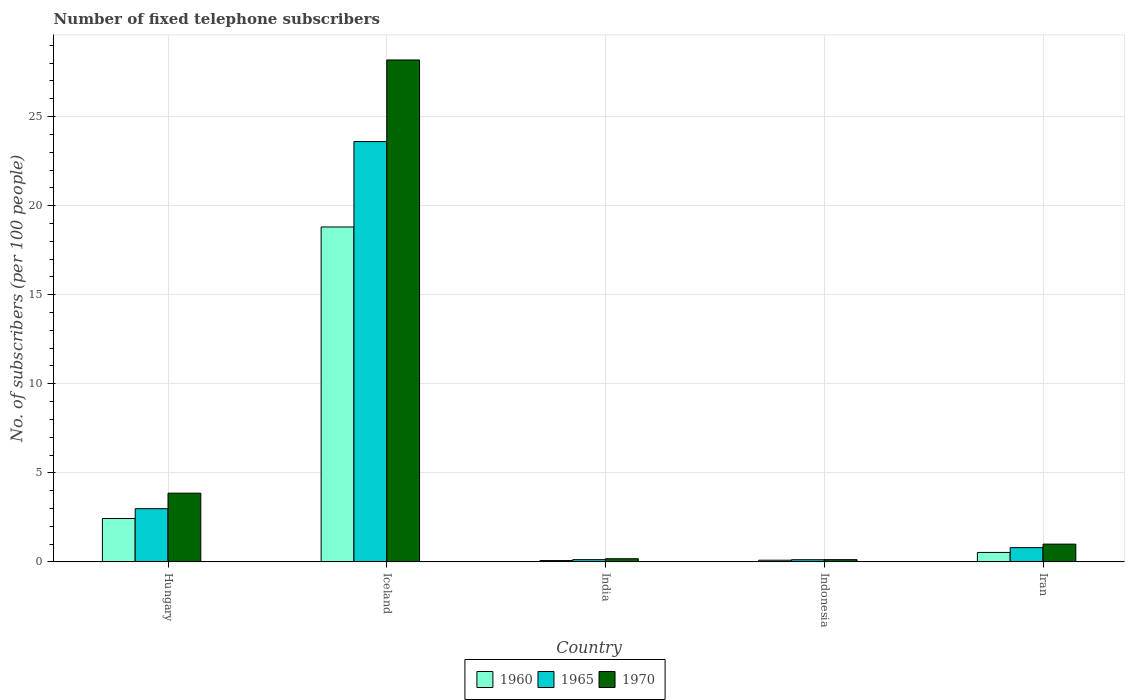Are the number of bars on each tick of the X-axis equal?
Provide a short and direct response. Yes. How many bars are there on the 3rd tick from the left?
Your answer should be very brief. 3. What is the label of the 5th group of bars from the left?
Give a very brief answer. Iran. In how many cases, is the number of bars for a given country not equal to the number of legend labels?
Provide a succinct answer. 0. What is the number of fixed telephone subscribers in 1970 in Iran?
Your answer should be very brief. 1. Across all countries, what is the maximum number of fixed telephone subscribers in 1970?
Your response must be concise. 28.18. Across all countries, what is the minimum number of fixed telephone subscribers in 1960?
Your answer should be compact. 0.07. What is the total number of fixed telephone subscribers in 1965 in the graph?
Your response must be concise. 27.63. What is the difference between the number of fixed telephone subscribers in 1965 in India and that in Indonesia?
Your response must be concise. 0. What is the difference between the number of fixed telephone subscribers in 1960 in Indonesia and the number of fixed telephone subscribers in 1970 in Iceland?
Ensure brevity in your answer.  -28.08. What is the average number of fixed telephone subscribers in 1965 per country?
Keep it short and to the point. 5.53. What is the difference between the number of fixed telephone subscribers of/in 1965 and number of fixed telephone subscribers of/in 1960 in Indonesia?
Make the answer very short. 0.03. What is the ratio of the number of fixed telephone subscribers in 1960 in Iceland to that in Indonesia?
Ensure brevity in your answer.  201.24. Is the number of fixed telephone subscribers in 1965 in Indonesia less than that in Iran?
Offer a terse response. Yes. What is the difference between the highest and the second highest number of fixed telephone subscribers in 1970?
Offer a very short reply. -2.86. What is the difference between the highest and the lowest number of fixed telephone subscribers in 1965?
Your answer should be compact. 23.48. In how many countries, is the number of fixed telephone subscribers in 1965 greater than the average number of fixed telephone subscribers in 1965 taken over all countries?
Offer a terse response. 1. Is the sum of the number of fixed telephone subscribers in 1960 in Hungary and Iceland greater than the maximum number of fixed telephone subscribers in 1970 across all countries?
Provide a short and direct response. No. What does the 3rd bar from the right in India represents?
Offer a very short reply. 1960. Is it the case that in every country, the sum of the number of fixed telephone subscribers in 1965 and number of fixed telephone subscribers in 1960 is greater than the number of fixed telephone subscribers in 1970?
Keep it short and to the point. Yes. How many countries are there in the graph?
Give a very brief answer. 5. Does the graph contain grids?
Provide a short and direct response. Yes. What is the title of the graph?
Keep it short and to the point. Number of fixed telephone subscribers. What is the label or title of the Y-axis?
Ensure brevity in your answer.  No. of subscribers (per 100 people). What is the No. of subscribers (per 100 people) in 1960 in Hungary?
Provide a short and direct response. 2.43. What is the No. of subscribers (per 100 people) in 1965 in Hungary?
Your response must be concise. 2.99. What is the No. of subscribers (per 100 people) in 1970 in Hungary?
Provide a succinct answer. 3.86. What is the No. of subscribers (per 100 people) in 1960 in Iceland?
Make the answer very short. 18.8. What is the No. of subscribers (per 100 people) of 1965 in Iceland?
Provide a succinct answer. 23.6. What is the No. of subscribers (per 100 people) in 1970 in Iceland?
Provide a succinct answer. 28.18. What is the No. of subscribers (per 100 people) of 1960 in India?
Provide a short and direct response. 0.07. What is the No. of subscribers (per 100 people) in 1965 in India?
Your answer should be very brief. 0.13. What is the No. of subscribers (per 100 people) of 1970 in India?
Ensure brevity in your answer.  0.18. What is the No. of subscribers (per 100 people) in 1960 in Indonesia?
Your response must be concise. 0.09. What is the No. of subscribers (per 100 people) of 1965 in Indonesia?
Your answer should be very brief. 0.12. What is the No. of subscribers (per 100 people) in 1970 in Indonesia?
Provide a short and direct response. 0.13. What is the No. of subscribers (per 100 people) in 1960 in Iran?
Offer a very short reply. 0.53. What is the No. of subscribers (per 100 people) of 1965 in Iran?
Give a very brief answer. 0.8. What is the No. of subscribers (per 100 people) in 1970 in Iran?
Give a very brief answer. 1. Across all countries, what is the maximum No. of subscribers (per 100 people) in 1960?
Provide a short and direct response. 18.8. Across all countries, what is the maximum No. of subscribers (per 100 people) in 1965?
Your answer should be very brief. 23.6. Across all countries, what is the maximum No. of subscribers (per 100 people) in 1970?
Your answer should be very brief. 28.18. Across all countries, what is the minimum No. of subscribers (per 100 people) of 1960?
Give a very brief answer. 0.07. Across all countries, what is the minimum No. of subscribers (per 100 people) in 1965?
Ensure brevity in your answer.  0.12. Across all countries, what is the minimum No. of subscribers (per 100 people) in 1970?
Provide a short and direct response. 0.13. What is the total No. of subscribers (per 100 people) in 1960 in the graph?
Offer a very short reply. 21.93. What is the total No. of subscribers (per 100 people) in 1965 in the graph?
Give a very brief answer. 27.63. What is the total No. of subscribers (per 100 people) in 1970 in the graph?
Offer a very short reply. 33.33. What is the difference between the No. of subscribers (per 100 people) in 1960 in Hungary and that in Iceland?
Give a very brief answer. -16.37. What is the difference between the No. of subscribers (per 100 people) of 1965 in Hungary and that in Iceland?
Your answer should be very brief. -20.61. What is the difference between the No. of subscribers (per 100 people) in 1970 in Hungary and that in Iceland?
Offer a terse response. -24.32. What is the difference between the No. of subscribers (per 100 people) of 1960 in Hungary and that in India?
Offer a very short reply. 2.36. What is the difference between the No. of subscribers (per 100 people) in 1965 in Hungary and that in India?
Offer a terse response. 2.86. What is the difference between the No. of subscribers (per 100 people) in 1970 in Hungary and that in India?
Offer a very short reply. 3.68. What is the difference between the No. of subscribers (per 100 people) of 1960 in Hungary and that in Indonesia?
Provide a short and direct response. 2.34. What is the difference between the No. of subscribers (per 100 people) of 1965 in Hungary and that in Indonesia?
Offer a terse response. 2.87. What is the difference between the No. of subscribers (per 100 people) in 1970 in Hungary and that in Indonesia?
Provide a succinct answer. 3.73. What is the difference between the No. of subscribers (per 100 people) in 1960 in Hungary and that in Iran?
Your answer should be very brief. 1.9. What is the difference between the No. of subscribers (per 100 people) in 1965 in Hungary and that in Iran?
Provide a succinct answer. 2.19. What is the difference between the No. of subscribers (per 100 people) of 1970 in Hungary and that in Iran?
Offer a terse response. 2.86. What is the difference between the No. of subscribers (per 100 people) in 1960 in Iceland and that in India?
Ensure brevity in your answer.  18.73. What is the difference between the No. of subscribers (per 100 people) in 1965 in Iceland and that in India?
Ensure brevity in your answer.  23.47. What is the difference between the No. of subscribers (per 100 people) in 1970 in Iceland and that in India?
Keep it short and to the point. 28. What is the difference between the No. of subscribers (per 100 people) of 1960 in Iceland and that in Indonesia?
Keep it short and to the point. 18.71. What is the difference between the No. of subscribers (per 100 people) in 1965 in Iceland and that in Indonesia?
Offer a terse response. 23.48. What is the difference between the No. of subscribers (per 100 people) of 1970 in Iceland and that in Indonesia?
Make the answer very short. 28.05. What is the difference between the No. of subscribers (per 100 people) in 1960 in Iceland and that in Iran?
Offer a terse response. 18.27. What is the difference between the No. of subscribers (per 100 people) in 1965 in Iceland and that in Iran?
Offer a terse response. 22.8. What is the difference between the No. of subscribers (per 100 people) in 1970 in Iceland and that in Iran?
Keep it short and to the point. 27.18. What is the difference between the No. of subscribers (per 100 people) in 1960 in India and that in Indonesia?
Provide a succinct answer. -0.02. What is the difference between the No. of subscribers (per 100 people) in 1965 in India and that in Indonesia?
Make the answer very short. 0. What is the difference between the No. of subscribers (per 100 people) of 1970 in India and that in Indonesia?
Give a very brief answer. 0.05. What is the difference between the No. of subscribers (per 100 people) in 1960 in India and that in Iran?
Keep it short and to the point. -0.46. What is the difference between the No. of subscribers (per 100 people) in 1965 in India and that in Iran?
Make the answer very short. -0.67. What is the difference between the No. of subscribers (per 100 people) of 1970 in India and that in Iran?
Your response must be concise. -0.82. What is the difference between the No. of subscribers (per 100 people) of 1960 in Indonesia and that in Iran?
Ensure brevity in your answer.  -0.44. What is the difference between the No. of subscribers (per 100 people) of 1965 in Indonesia and that in Iran?
Your answer should be compact. -0.68. What is the difference between the No. of subscribers (per 100 people) in 1970 in Indonesia and that in Iran?
Offer a very short reply. -0.87. What is the difference between the No. of subscribers (per 100 people) in 1960 in Hungary and the No. of subscribers (per 100 people) in 1965 in Iceland?
Ensure brevity in your answer.  -21.16. What is the difference between the No. of subscribers (per 100 people) in 1960 in Hungary and the No. of subscribers (per 100 people) in 1970 in Iceland?
Ensure brevity in your answer.  -25.74. What is the difference between the No. of subscribers (per 100 people) in 1965 in Hungary and the No. of subscribers (per 100 people) in 1970 in Iceland?
Your response must be concise. -25.19. What is the difference between the No. of subscribers (per 100 people) in 1960 in Hungary and the No. of subscribers (per 100 people) in 1965 in India?
Your answer should be very brief. 2.31. What is the difference between the No. of subscribers (per 100 people) of 1960 in Hungary and the No. of subscribers (per 100 people) of 1970 in India?
Give a very brief answer. 2.26. What is the difference between the No. of subscribers (per 100 people) in 1965 in Hungary and the No. of subscribers (per 100 people) in 1970 in India?
Your answer should be very brief. 2.81. What is the difference between the No. of subscribers (per 100 people) in 1960 in Hungary and the No. of subscribers (per 100 people) in 1965 in Indonesia?
Give a very brief answer. 2.31. What is the difference between the No. of subscribers (per 100 people) of 1960 in Hungary and the No. of subscribers (per 100 people) of 1970 in Indonesia?
Make the answer very short. 2.31. What is the difference between the No. of subscribers (per 100 people) in 1965 in Hungary and the No. of subscribers (per 100 people) in 1970 in Indonesia?
Provide a short and direct response. 2.86. What is the difference between the No. of subscribers (per 100 people) in 1960 in Hungary and the No. of subscribers (per 100 people) in 1965 in Iran?
Make the answer very short. 1.63. What is the difference between the No. of subscribers (per 100 people) in 1960 in Hungary and the No. of subscribers (per 100 people) in 1970 in Iran?
Your response must be concise. 1.44. What is the difference between the No. of subscribers (per 100 people) of 1965 in Hungary and the No. of subscribers (per 100 people) of 1970 in Iran?
Provide a succinct answer. 1.99. What is the difference between the No. of subscribers (per 100 people) in 1960 in Iceland and the No. of subscribers (per 100 people) in 1965 in India?
Offer a very short reply. 18.68. What is the difference between the No. of subscribers (per 100 people) of 1960 in Iceland and the No. of subscribers (per 100 people) of 1970 in India?
Your response must be concise. 18.62. What is the difference between the No. of subscribers (per 100 people) of 1965 in Iceland and the No. of subscribers (per 100 people) of 1970 in India?
Ensure brevity in your answer.  23.42. What is the difference between the No. of subscribers (per 100 people) in 1960 in Iceland and the No. of subscribers (per 100 people) in 1965 in Indonesia?
Your answer should be compact. 18.68. What is the difference between the No. of subscribers (per 100 people) of 1960 in Iceland and the No. of subscribers (per 100 people) of 1970 in Indonesia?
Keep it short and to the point. 18.68. What is the difference between the No. of subscribers (per 100 people) of 1965 in Iceland and the No. of subscribers (per 100 people) of 1970 in Indonesia?
Give a very brief answer. 23.47. What is the difference between the No. of subscribers (per 100 people) in 1960 in Iceland and the No. of subscribers (per 100 people) in 1965 in Iran?
Ensure brevity in your answer.  18. What is the difference between the No. of subscribers (per 100 people) of 1960 in Iceland and the No. of subscribers (per 100 people) of 1970 in Iran?
Your response must be concise. 17.8. What is the difference between the No. of subscribers (per 100 people) of 1965 in Iceland and the No. of subscribers (per 100 people) of 1970 in Iran?
Offer a very short reply. 22.6. What is the difference between the No. of subscribers (per 100 people) in 1960 in India and the No. of subscribers (per 100 people) in 1965 in Indonesia?
Provide a succinct answer. -0.05. What is the difference between the No. of subscribers (per 100 people) of 1960 in India and the No. of subscribers (per 100 people) of 1970 in Indonesia?
Offer a very short reply. -0.05. What is the difference between the No. of subscribers (per 100 people) of 1965 in India and the No. of subscribers (per 100 people) of 1970 in Indonesia?
Provide a succinct answer. -0. What is the difference between the No. of subscribers (per 100 people) in 1960 in India and the No. of subscribers (per 100 people) in 1965 in Iran?
Your answer should be very brief. -0.73. What is the difference between the No. of subscribers (per 100 people) of 1960 in India and the No. of subscribers (per 100 people) of 1970 in Iran?
Your answer should be very brief. -0.92. What is the difference between the No. of subscribers (per 100 people) in 1965 in India and the No. of subscribers (per 100 people) in 1970 in Iran?
Your answer should be compact. -0.87. What is the difference between the No. of subscribers (per 100 people) in 1960 in Indonesia and the No. of subscribers (per 100 people) in 1965 in Iran?
Give a very brief answer. -0.71. What is the difference between the No. of subscribers (per 100 people) of 1960 in Indonesia and the No. of subscribers (per 100 people) of 1970 in Iran?
Provide a short and direct response. -0.9. What is the difference between the No. of subscribers (per 100 people) in 1965 in Indonesia and the No. of subscribers (per 100 people) in 1970 in Iran?
Keep it short and to the point. -0.88. What is the average No. of subscribers (per 100 people) of 1960 per country?
Your answer should be compact. 4.39. What is the average No. of subscribers (per 100 people) of 1965 per country?
Provide a succinct answer. 5.53. What is the difference between the No. of subscribers (per 100 people) in 1960 and No. of subscribers (per 100 people) in 1965 in Hungary?
Offer a terse response. -0.55. What is the difference between the No. of subscribers (per 100 people) in 1960 and No. of subscribers (per 100 people) in 1970 in Hungary?
Your answer should be compact. -1.42. What is the difference between the No. of subscribers (per 100 people) of 1965 and No. of subscribers (per 100 people) of 1970 in Hungary?
Keep it short and to the point. -0.87. What is the difference between the No. of subscribers (per 100 people) of 1960 and No. of subscribers (per 100 people) of 1965 in Iceland?
Your response must be concise. -4.8. What is the difference between the No. of subscribers (per 100 people) of 1960 and No. of subscribers (per 100 people) of 1970 in Iceland?
Offer a very short reply. -9.38. What is the difference between the No. of subscribers (per 100 people) in 1965 and No. of subscribers (per 100 people) in 1970 in Iceland?
Your answer should be very brief. -4.58. What is the difference between the No. of subscribers (per 100 people) of 1960 and No. of subscribers (per 100 people) of 1965 in India?
Make the answer very short. -0.05. What is the difference between the No. of subscribers (per 100 people) in 1960 and No. of subscribers (per 100 people) in 1970 in India?
Provide a short and direct response. -0.1. What is the difference between the No. of subscribers (per 100 people) in 1965 and No. of subscribers (per 100 people) in 1970 in India?
Ensure brevity in your answer.  -0.05. What is the difference between the No. of subscribers (per 100 people) of 1960 and No. of subscribers (per 100 people) of 1965 in Indonesia?
Your answer should be compact. -0.03. What is the difference between the No. of subscribers (per 100 people) of 1960 and No. of subscribers (per 100 people) of 1970 in Indonesia?
Provide a short and direct response. -0.03. What is the difference between the No. of subscribers (per 100 people) in 1965 and No. of subscribers (per 100 people) in 1970 in Indonesia?
Provide a short and direct response. -0. What is the difference between the No. of subscribers (per 100 people) of 1960 and No. of subscribers (per 100 people) of 1965 in Iran?
Provide a succinct answer. -0.27. What is the difference between the No. of subscribers (per 100 people) of 1960 and No. of subscribers (per 100 people) of 1970 in Iran?
Ensure brevity in your answer.  -0.47. What is the difference between the No. of subscribers (per 100 people) in 1965 and No. of subscribers (per 100 people) in 1970 in Iran?
Your response must be concise. -0.2. What is the ratio of the No. of subscribers (per 100 people) of 1960 in Hungary to that in Iceland?
Provide a short and direct response. 0.13. What is the ratio of the No. of subscribers (per 100 people) in 1965 in Hungary to that in Iceland?
Offer a very short reply. 0.13. What is the ratio of the No. of subscribers (per 100 people) of 1970 in Hungary to that in Iceland?
Ensure brevity in your answer.  0.14. What is the ratio of the No. of subscribers (per 100 people) in 1960 in Hungary to that in India?
Offer a very short reply. 32.92. What is the ratio of the No. of subscribers (per 100 people) of 1965 in Hungary to that in India?
Your response must be concise. 23.86. What is the ratio of the No. of subscribers (per 100 people) in 1970 in Hungary to that in India?
Provide a short and direct response. 21.82. What is the ratio of the No. of subscribers (per 100 people) of 1960 in Hungary to that in Indonesia?
Your answer should be very brief. 26.05. What is the ratio of the No. of subscribers (per 100 people) of 1965 in Hungary to that in Indonesia?
Give a very brief answer. 24.76. What is the ratio of the No. of subscribers (per 100 people) of 1970 in Hungary to that in Indonesia?
Ensure brevity in your answer.  30.77. What is the ratio of the No. of subscribers (per 100 people) in 1960 in Hungary to that in Iran?
Your answer should be compact. 4.59. What is the ratio of the No. of subscribers (per 100 people) of 1965 in Hungary to that in Iran?
Make the answer very short. 3.74. What is the ratio of the No. of subscribers (per 100 people) of 1970 in Hungary to that in Iran?
Make the answer very short. 3.87. What is the ratio of the No. of subscribers (per 100 people) of 1960 in Iceland to that in India?
Give a very brief answer. 254.3. What is the ratio of the No. of subscribers (per 100 people) of 1965 in Iceland to that in India?
Give a very brief answer. 188.49. What is the ratio of the No. of subscribers (per 100 people) in 1970 in Iceland to that in India?
Offer a very short reply. 159.41. What is the ratio of the No. of subscribers (per 100 people) in 1960 in Iceland to that in Indonesia?
Offer a terse response. 201.24. What is the ratio of the No. of subscribers (per 100 people) of 1965 in Iceland to that in Indonesia?
Your response must be concise. 195.66. What is the ratio of the No. of subscribers (per 100 people) of 1970 in Iceland to that in Indonesia?
Offer a terse response. 224.77. What is the ratio of the No. of subscribers (per 100 people) in 1960 in Iceland to that in Iran?
Offer a very short reply. 35.46. What is the ratio of the No. of subscribers (per 100 people) of 1965 in Iceland to that in Iran?
Your response must be concise. 29.52. What is the ratio of the No. of subscribers (per 100 people) of 1970 in Iceland to that in Iran?
Your response must be concise. 28.28. What is the ratio of the No. of subscribers (per 100 people) of 1960 in India to that in Indonesia?
Provide a short and direct response. 0.79. What is the ratio of the No. of subscribers (per 100 people) in 1965 in India to that in Indonesia?
Keep it short and to the point. 1.04. What is the ratio of the No. of subscribers (per 100 people) of 1970 in India to that in Indonesia?
Give a very brief answer. 1.41. What is the ratio of the No. of subscribers (per 100 people) in 1960 in India to that in Iran?
Keep it short and to the point. 0.14. What is the ratio of the No. of subscribers (per 100 people) in 1965 in India to that in Iran?
Your answer should be compact. 0.16. What is the ratio of the No. of subscribers (per 100 people) of 1970 in India to that in Iran?
Give a very brief answer. 0.18. What is the ratio of the No. of subscribers (per 100 people) in 1960 in Indonesia to that in Iran?
Make the answer very short. 0.18. What is the ratio of the No. of subscribers (per 100 people) of 1965 in Indonesia to that in Iran?
Provide a short and direct response. 0.15. What is the ratio of the No. of subscribers (per 100 people) of 1970 in Indonesia to that in Iran?
Give a very brief answer. 0.13. What is the difference between the highest and the second highest No. of subscribers (per 100 people) in 1960?
Provide a succinct answer. 16.37. What is the difference between the highest and the second highest No. of subscribers (per 100 people) of 1965?
Your response must be concise. 20.61. What is the difference between the highest and the second highest No. of subscribers (per 100 people) of 1970?
Provide a succinct answer. 24.32. What is the difference between the highest and the lowest No. of subscribers (per 100 people) of 1960?
Your answer should be very brief. 18.73. What is the difference between the highest and the lowest No. of subscribers (per 100 people) of 1965?
Provide a succinct answer. 23.48. What is the difference between the highest and the lowest No. of subscribers (per 100 people) of 1970?
Offer a terse response. 28.05. 